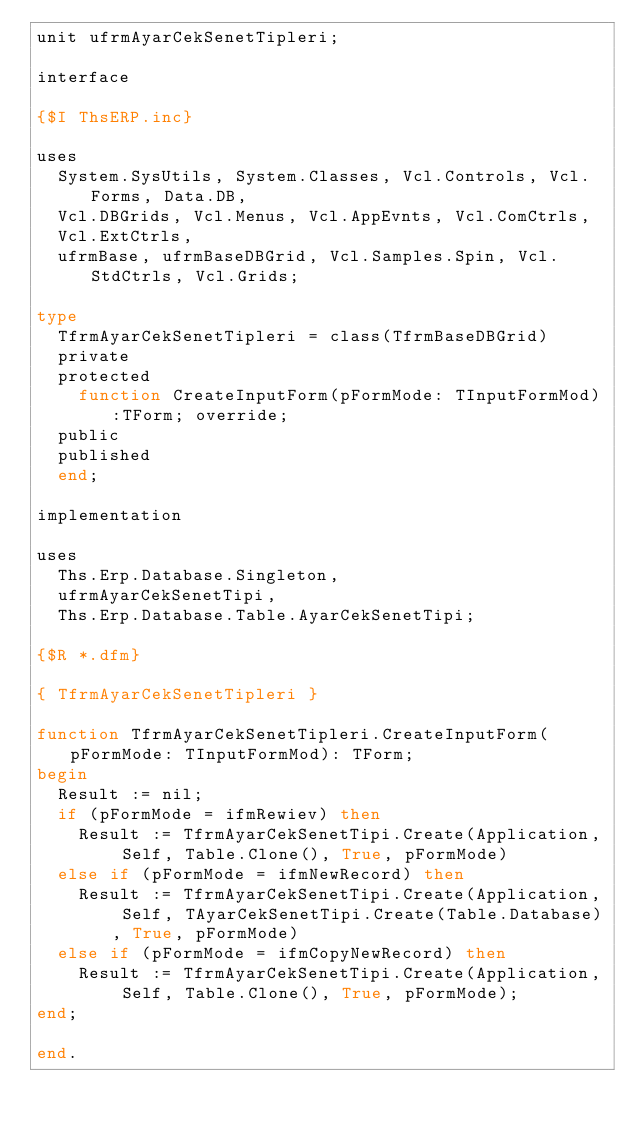<code> <loc_0><loc_0><loc_500><loc_500><_Pascal_>unit ufrmAyarCekSenetTipleri;

interface

{$I ThsERP.inc}

uses
  System.SysUtils, System.Classes, Vcl.Controls, Vcl.Forms, Data.DB,
  Vcl.DBGrids, Vcl.Menus, Vcl.AppEvnts, Vcl.ComCtrls,
  Vcl.ExtCtrls,
  ufrmBase, ufrmBaseDBGrid, Vcl.Samples.Spin, Vcl.StdCtrls, Vcl.Grids;

type
  TfrmAyarCekSenetTipleri = class(TfrmBaseDBGrid)
  private
  protected
    function CreateInputForm(pFormMode: TInputFormMod):TForm; override;
  public
  published
  end;

implementation

uses
  Ths.Erp.Database.Singleton,
  ufrmAyarCekSenetTipi,
  Ths.Erp.Database.Table.AyarCekSenetTipi;

{$R *.dfm}

{ TfrmAyarCekSenetTipleri }

function TfrmAyarCekSenetTipleri.CreateInputForm(pFormMode: TInputFormMod): TForm;
begin
  Result := nil;
  if (pFormMode = ifmRewiev) then
    Result := TfrmAyarCekSenetTipi.Create(Application, Self, Table.Clone(), True, pFormMode)
  else if (pFormMode = ifmNewRecord) then
    Result := TfrmAyarCekSenetTipi.Create(Application, Self, TAyarCekSenetTipi.Create(Table.Database), True, pFormMode)
  else if (pFormMode = ifmCopyNewRecord) then
    Result := TfrmAyarCekSenetTipi.Create(Application, Self, Table.Clone(), True, pFormMode);
end;

end.
</code> 